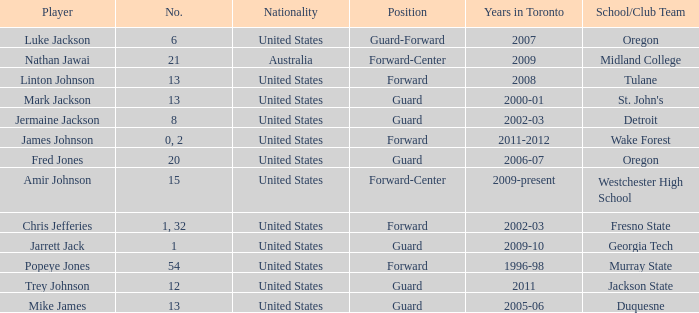What school/club team is Trey Johnson on? Jackson State. 